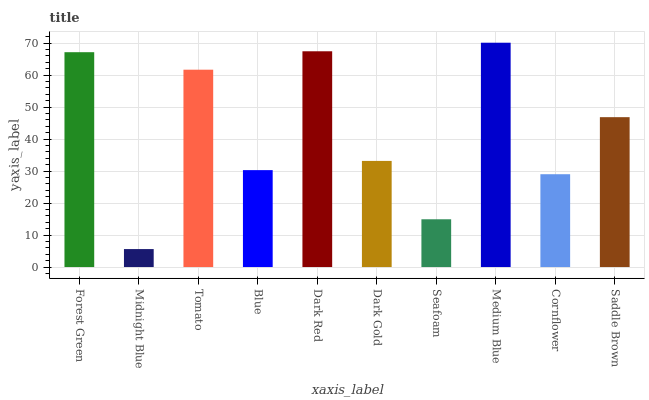Is Midnight Blue the minimum?
Answer yes or no. Yes. Is Medium Blue the maximum?
Answer yes or no. Yes. Is Tomato the minimum?
Answer yes or no. No. Is Tomato the maximum?
Answer yes or no. No. Is Tomato greater than Midnight Blue?
Answer yes or no. Yes. Is Midnight Blue less than Tomato?
Answer yes or no. Yes. Is Midnight Blue greater than Tomato?
Answer yes or no. No. Is Tomato less than Midnight Blue?
Answer yes or no. No. Is Saddle Brown the high median?
Answer yes or no. Yes. Is Dark Gold the low median?
Answer yes or no. Yes. Is Blue the high median?
Answer yes or no. No. Is Tomato the low median?
Answer yes or no. No. 